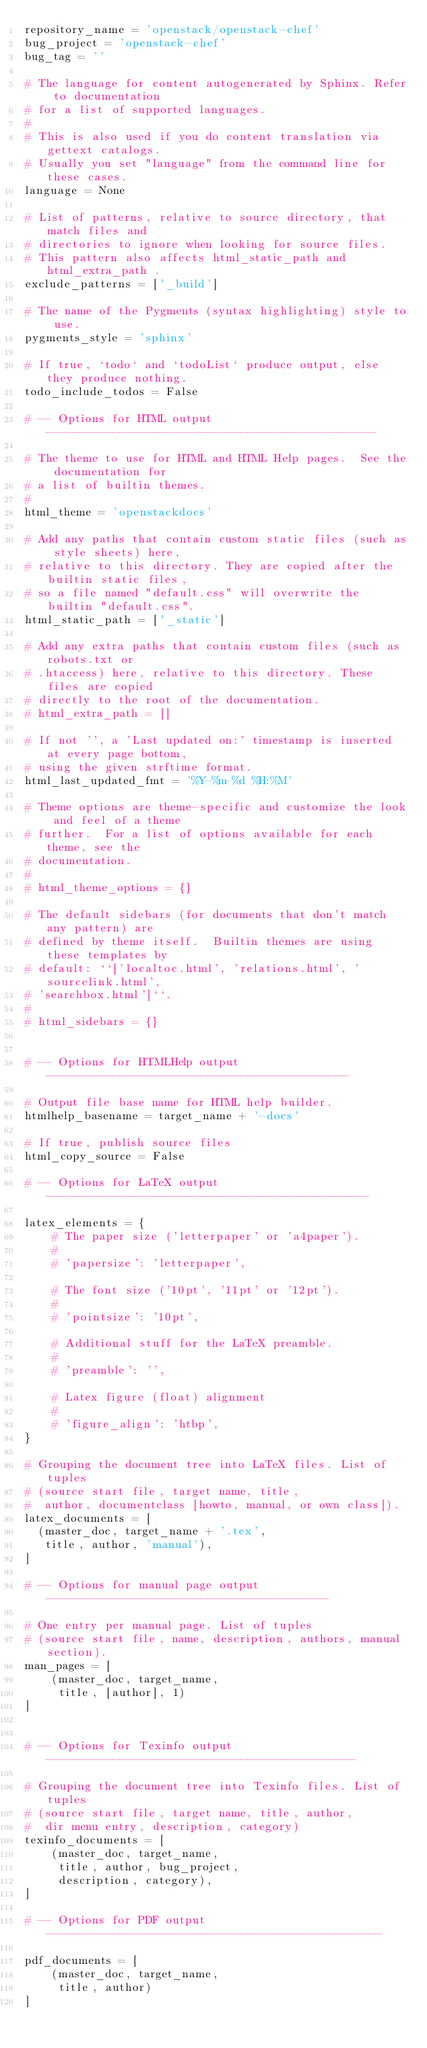<code> <loc_0><loc_0><loc_500><loc_500><_Python_>repository_name = 'openstack/openstack-chef'
bug_project = 'openstack-chef'
bug_tag = ''

# The language for content autogenerated by Sphinx. Refer to documentation
# for a list of supported languages.
#
# This is also used if you do content translation via gettext catalogs.
# Usually you set "language" from the command line for these cases.
language = None

# List of patterns, relative to source directory, that match files and
# directories to ignore when looking for source files.
# This pattern also affects html_static_path and html_extra_path .
exclude_patterns = ['_build']

# The name of the Pygments (syntax highlighting) style to use.
pygments_style = 'sphinx'

# If true, `todo` and `todoList` produce output, else they produce nothing.
todo_include_todos = False

# -- Options for HTML output -------------------------------------------------

# The theme to use for HTML and HTML Help pages.  See the documentation for
# a list of builtin themes.
#
html_theme = 'openstackdocs'

# Add any paths that contain custom static files (such as style sheets) here,
# relative to this directory. They are copied after the builtin static files,
# so a file named "default.css" will overwrite the builtin "default.css".
html_static_path = ['_static']

# Add any extra paths that contain custom files (such as robots.txt or
# .htaccess) here, relative to this directory. These files are copied
# directly to the root of the documentation.
# html_extra_path = []

# If not '', a 'Last updated on:' timestamp is inserted at every page bottom,
# using the given strftime format.
html_last_updated_fmt = '%Y-%m-%d %H:%M'

# Theme options are theme-specific and customize the look and feel of a theme
# further.  For a list of options available for each theme, see the
# documentation.
#
# html_theme_options = {}

# The default sidebars (for documents that don't match any pattern) are
# defined by theme itself.  Builtin themes are using these templates by
# default: ``['localtoc.html', 'relations.html', 'sourcelink.html',
# 'searchbox.html']``.
#
# html_sidebars = {}


# -- Options for HTMLHelp output ---------------------------------------------

# Output file base name for HTML help builder.
htmlhelp_basename = target_name + '-docs'

# If true, publish source files
html_copy_source = False

# -- Options for LaTeX output ------------------------------------------------

latex_elements = {
    # The paper size ('letterpaper' or 'a4paper').
    #
    # 'papersize': 'letterpaper',

    # The font size ('10pt', '11pt' or '12pt').
    #
    # 'pointsize': '10pt',

    # Additional stuff for the LaTeX preamble.
    #
    # 'preamble': '',

    # Latex figure (float) alignment
    #
    # 'figure_align': 'htbp',
}

# Grouping the document tree into LaTeX files. List of tuples
# (source start file, target name, title,
#  author, documentclass [howto, manual, or own class]).
latex_documents = [
  (master_doc, target_name + '.tex',
   title, author, 'manual'),
]

# -- Options for manual page output ------------------------------------------

# One entry per manual page. List of tuples
# (source start file, name, description, authors, manual section).
man_pages = [
    (master_doc, target_name,
     title, [author], 1)
]


# -- Options for Texinfo output ----------------------------------------------

# Grouping the document tree into Texinfo files. List of tuples
# (source start file, target name, title, author,
#  dir menu entry, description, category)
texinfo_documents = [
    (master_doc, target_name,
     title, author, bug_project,
     description, category),
]

# -- Options for PDF output --------------------------------------------------

pdf_documents = [
    (master_doc, target_name,
     title, author)
]

</code> 